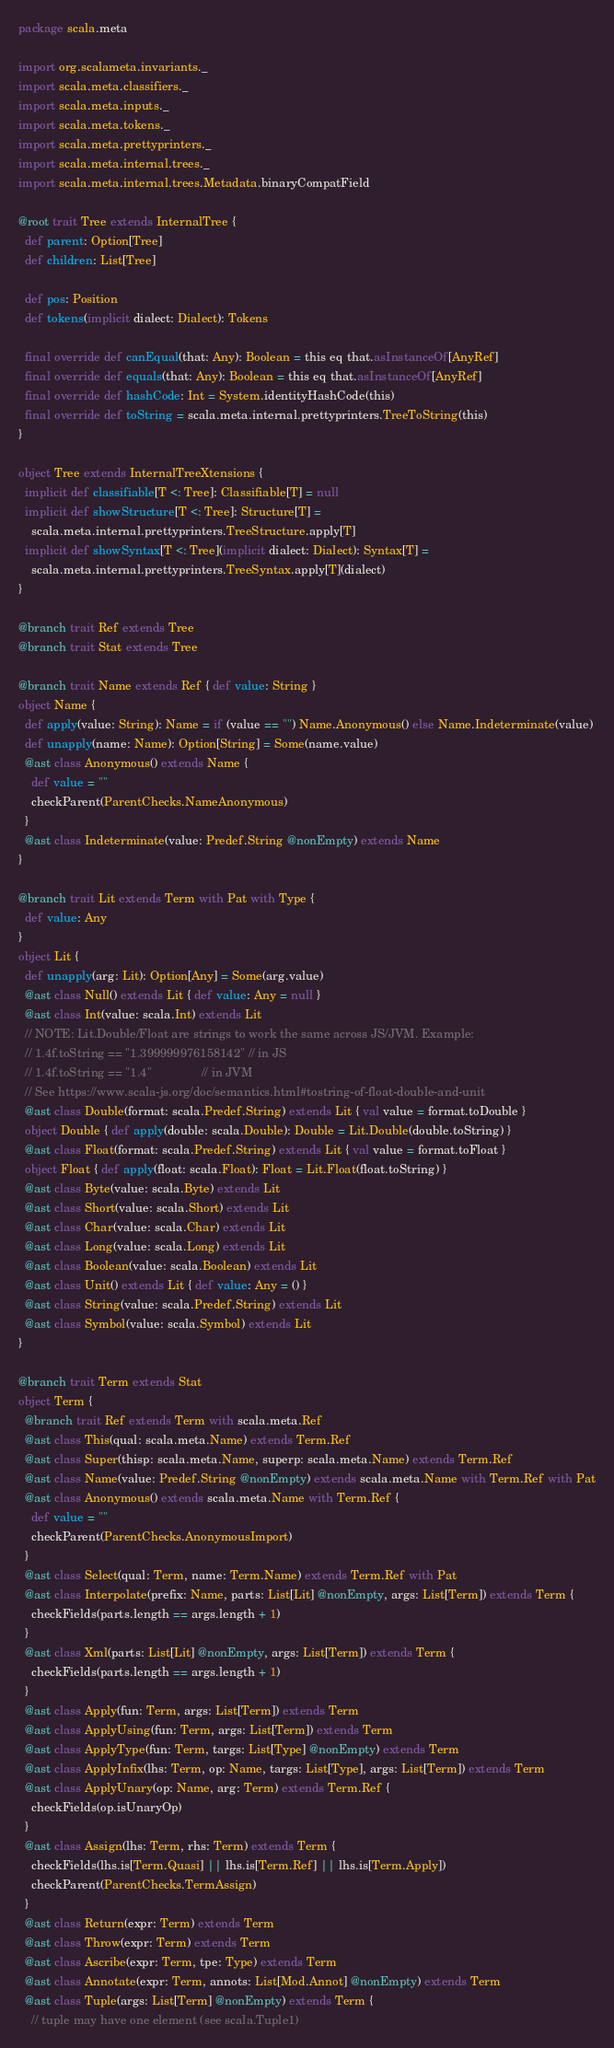Convert code to text. <code><loc_0><loc_0><loc_500><loc_500><_Scala_>package scala.meta

import org.scalameta.invariants._
import scala.meta.classifiers._
import scala.meta.inputs._
import scala.meta.tokens._
import scala.meta.prettyprinters._
import scala.meta.internal.trees._
import scala.meta.internal.trees.Metadata.binaryCompatField

@root trait Tree extends InternalTree {
  def parent: Option[Tree]
  def children: List[Tree]

  def pos: Position
  def tokens(implicit dialect: Dialect): Tokens

  final override def canEqual(that: Any): Boolean = this eq that.asInstanceOf[AnyRef]
  final override def equals(that: Any): Boolean = this eq that.asInstanceOf[AnyRef]
  final override def hashCode: Int = System.identityHashCode(this)
  final override def toString = scala.meta.internal.prettyprinters.TreeToString(this)
}

object Tree extends InternalTreeXtensions {
  implicit def classifiable[T <: Tree]: Classifiable[T] = null
  implicit def showStructure[T <: Tree]: Structure[T] =
    scala.meta.internal.prettyprinters.TreeStructure.apply[T]
  implicit def showSyntax[T <: Tree](implicit dialect: Dialect): Syntax[T] =
    scala.meta.internal.prettyprinters.TreeSyntax.apply[T](dialect)
}

@branch trait Ref extends Tree
@branch trait Stat extends Tree

@branch trait Name extends Ref { def value: String }
object Name {
  def apply(value: String): Name = if (value == "") Name.Anonymous() else Name.Indeterminate(value)
  def unapply(name: Name): Option[String] = Some(name.value)
  @ast class Anonymous() extends Name {
    def value = ""
    checkParent(ParentChecks.NameAnonymous)
  }
  @ast class Indeterminate(value: Predef.String @nonEmpty) extends Name
}

@branch trait Lit extends Term with Pat with Type {
  def value: Any
}
object Lit {
  def unapply(arg: Lit): Option[Any] = Some(arg.value)
  @ast class Null() extends Lit { def value: Any = null }
  @ast class Int(value: scala.Int) extends Lit
  // NOTE: Lit.Double/Float are strings to work the same across JS/JVM. Example:
  // 1.4f.toString == "1.399999976158142" // in JS
  // 1.4f.toString == "1.4"               // in JVM
  // See https://www.scala-js.org/doc/semantics.html#tostring-of-float-double-and-unit
  @ast class Double(format: scala.Predef.String) extends Lit { val value = format.toDouble }
  object Double { def apply(double: scala.Double): Double = Lit.Double(double.toString) }
  @ast class Float(format: scala.Predef.String) extends Lit { val value = format.toFloat }
  object Float { def apply(float: scala.Float): Float = Lit.Float(float.toString) }
  @ast class Byte(value: scala.Byte) extends Lit
  @ast class Short(value: scala.Short) extends Lit
  @ast class Char(value: scala.Char) extends Lit
  @ast class Long(value: scala.Long) extends Lit
  @ast class Boolean(value: scala.Boolean) extends Lit
  @ast class Unit() extends Lit { def value: Any = () }
  @ast class String(value: scala.Predef.String) extends Lit
  @ast class Symbol(value: scala.Symbol) extends Lit
}

@branch trait Term extends Stat
object Term {
  @branch trait Ref extends Term with scala.meta.Ref
  @ast class This(qual: scala.meta.Name) extends Term.Ref
  @ast class Super(thisp: scala.meta.Name, superp: scala.meta.Name) extends Term.Ref
  @ast class Name(value: Predef.String @nonEmpty) extends scala.meta.Name with Term.Ref with Pat
  @ast class Anonymous() extends scala.meta.Name with Term.Ref {
    def value = ""
    checkParent(ParentChecks.AnonymousImport)
  }
  @ast class Select(qual: Term, name: Term.Name) extends Term.Ref with Pat
  @ast class Interpolate(prefix: Name, parts: List[Lit] @nonEmpty, args: List[Term]) extends Term {
    checkFields(parts.length == args.length + 1)
  }
  @ast class Xml(parts: List[Lit] @nonEmpty, args: List[Term]) extends Term {
    checkFields(parts.length == args.length + 1)
  }
  @ast class Apply(fun: Term, args: List[Term]) extends Term
  @ast class ApplyUsing(fun: Term, args: List[Term]) extends Term
  @ast class ApplyType(fun: Term, targs: List[Type] @nonEmpty) extends Term
  @ast class ApplyInfix(lhs: Term, op: Name, targs: List[Type], args: List[Term]) extends Term
  @ast class ApplyUnary(op: Name, arg: Term) extends Term.Ref {
    checkFields(op.isUnaryOp)
  }
  @ast class Assign(lhs: Term, rhs: Term) extends Term {
    checkFields(lhs.is[Term.Quasi] || lhs.is[Term.Ref] || lhs.is[Term.Apply])
    checkParent(ParentChecks.TermAssign)
  }
  @ast class Return(expr: Term) extends Term
  @ast class Throw(expr: Term) extends Term
  @ast class Ascribe(expr: Term, tpe: Type) extends Term
  @ast class Annotate(expr: Term, annots: List[Mod.Annot] @nonEmpty) extends Term
  @ast class Tuple(args: List[Term] @nonEmpty) extends Term {
    // tuple may have one element (see scala.Tuple1)</code> 